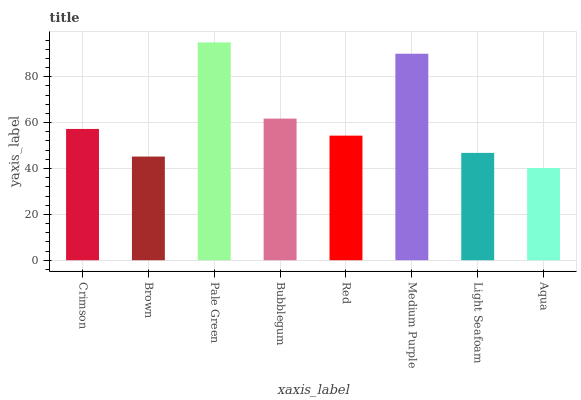Is Aqua the minimum?
Answer yes or no. Yes. Is Pale Green the maximum?
Answer yes or no. Yes. Is Brown the minimum?
Answer yes or no. No. Is Brown the maximum?
Answer yes or no. No. Is Crimson greater than Brown?
Answer yes or no. Yes. Is Brown less than Crimson?
Answer yes or no. Yes. Is Brown greater than Crimson?
Answer yes or no. No. Is Crimson less than Brown?
Answer yes or no. No. Is Crimson the high median?
Answer yes or no. Yes. Is Red the low median?
Answer yes or no. Yes. Is Aqua the high median?
Answer yes or no. No. Is Bubblegum the low median?
Answer yes or no. No. 